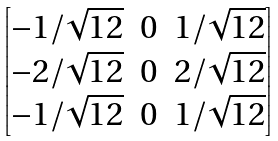Convert formula to latex. <formula><loc_0><loc_0><loc_500><loc_500>\begin{bmatrix} - 1 / \sqrt { 1 2 } & 0 & 1 / \sqrt { 1 2 } \\ - 2 / \sqrt { 1 2 } & 0 & 2 / \sqrt { 1 2 } \\ - 1 / \sqrt { 1 2 } & 0 & 1 / \sqrt { 1 2 } \end{bmatrix}</formula> 